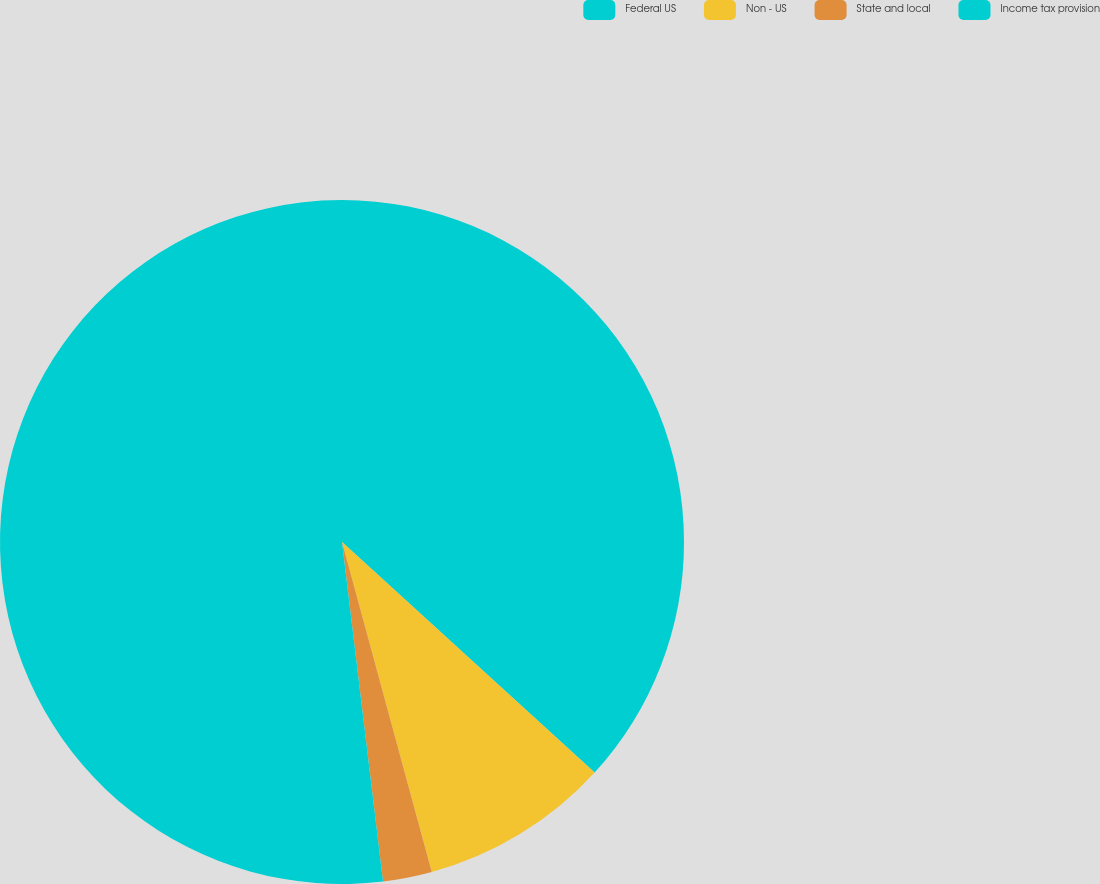Convert chart. <chart><loc_0><loc_0><loc_500><loc_500><pie_chart><fcel>Federal US<fcel>Non - US<fcel>State and local<fcel>Income tax provision<nl><fcel>36.77%<fcel>9.0%<fcel>2.31%<fcel>51.91%<nl></chart> 